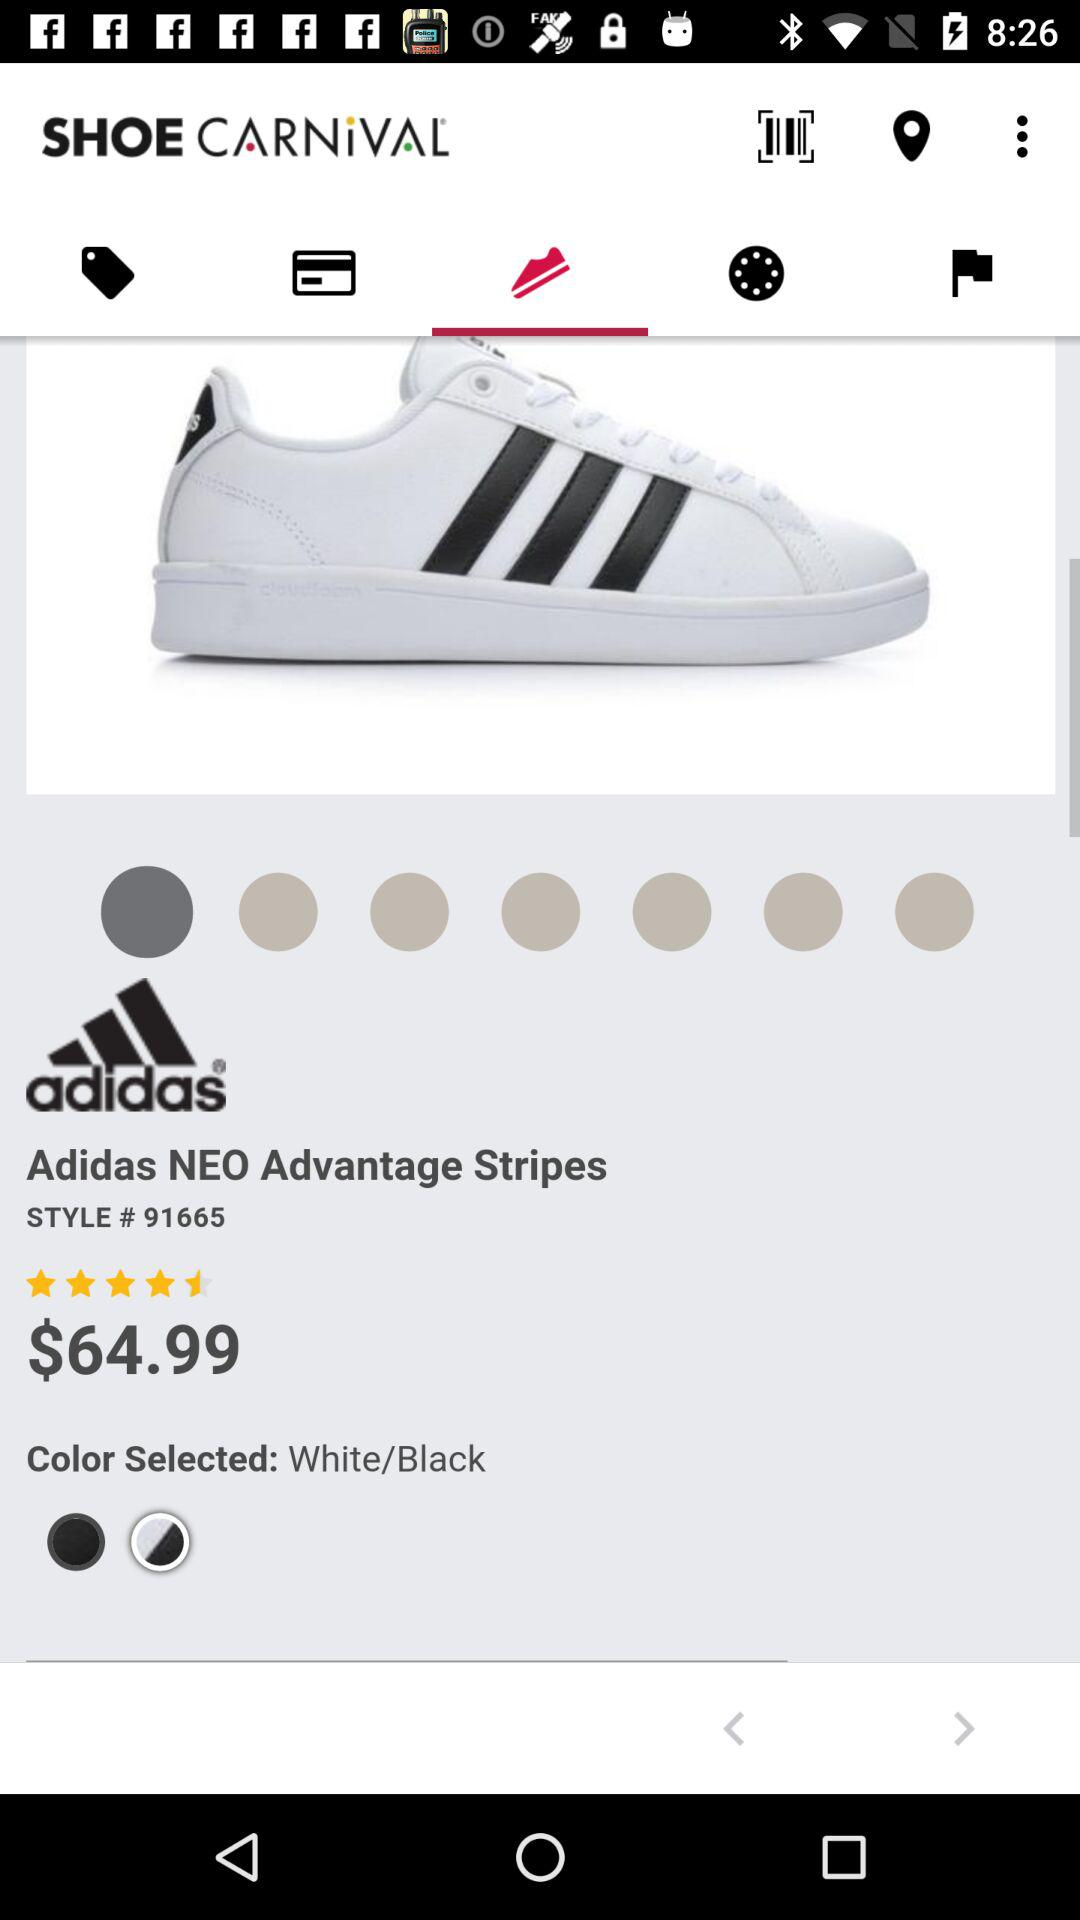How many rating stars are on "Adidas NEO Advantage Stripes"? The rating is 4.5 stars. 